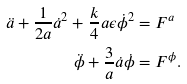Convert formula to latex. <formula><loc_0><loc_0><loc_500><loc_500>\ddot { a } + \frac { 1 } { 2 a } \dot { a } ^ { 2 } + \frac { k } { 4 } a \epsilon \dot { \phi } ^ { 2 } & = F ^ { a } \\ \ddot { \phi } + \frac { 3 } { a } \dot { a } \dot { \phi } & = F ^ { \phi } .</formula> 